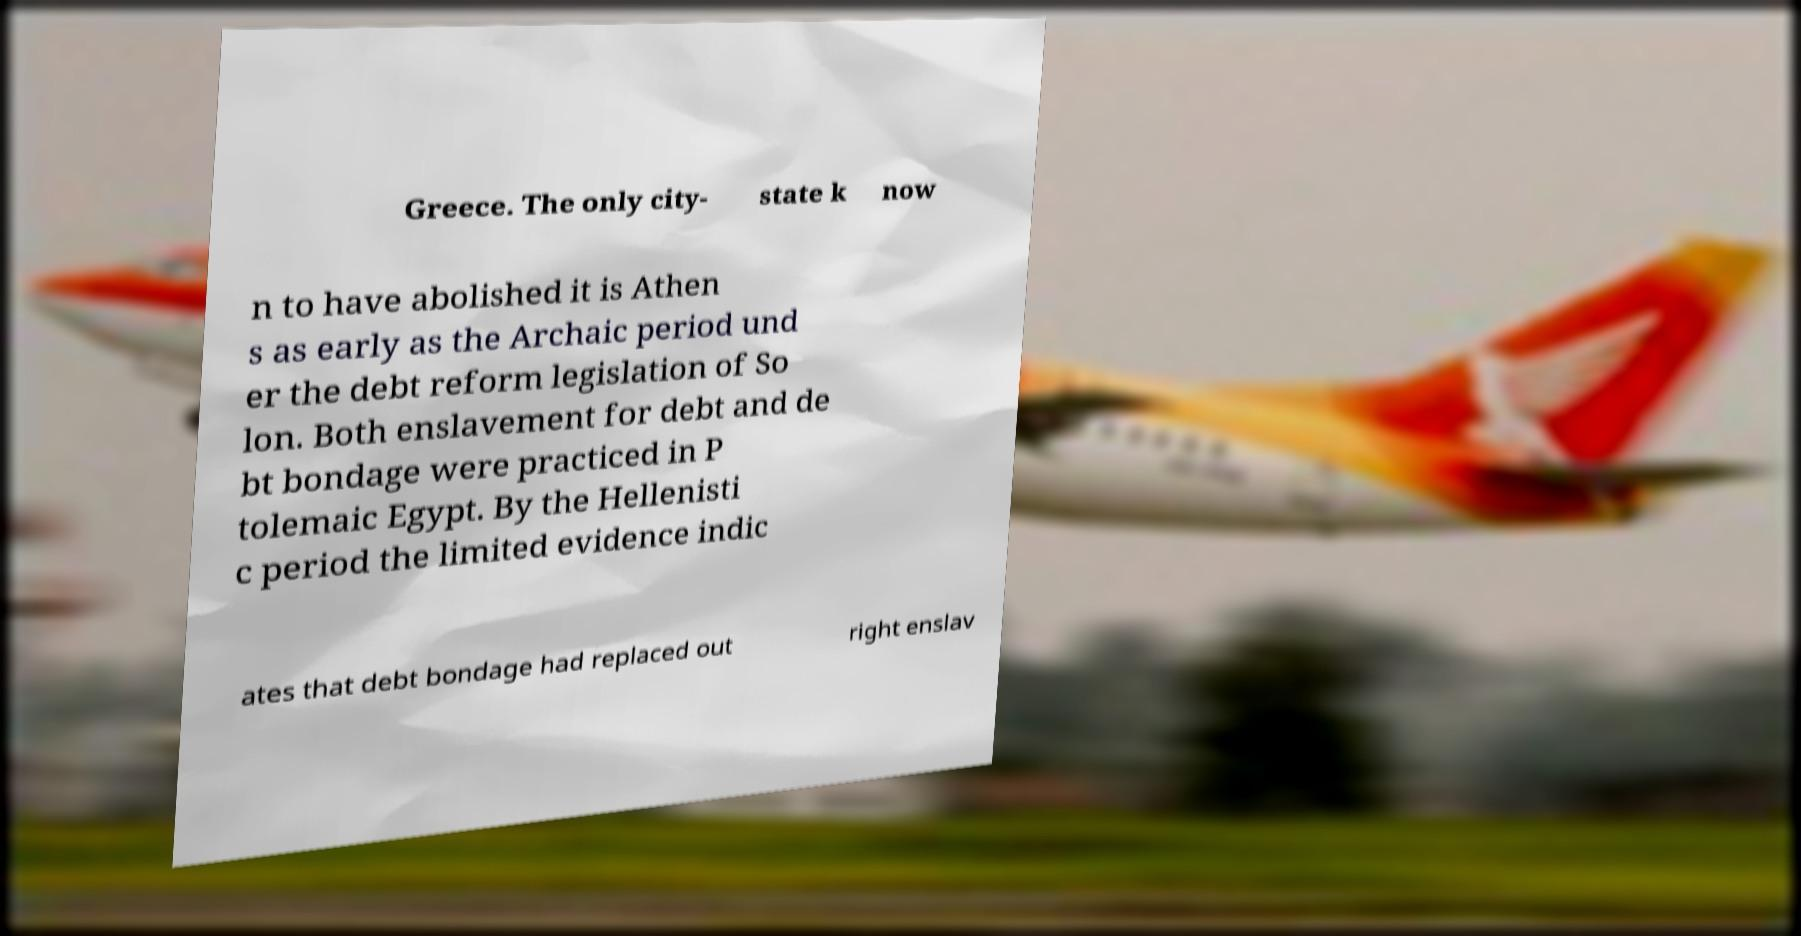What messages or text are displayed in this image? I need them in a readable, typed format. Greece. The only city- state k now n to have abolished it is Athen s as early as the Archaic period und er the debt reform legislation of So lon. Both enslavement for debt and de bt bondage were practiced in P tolemaic Egypt. By the Hellenisti c period the limited evidence indic ates that debt bondage had replaced out right enslav 